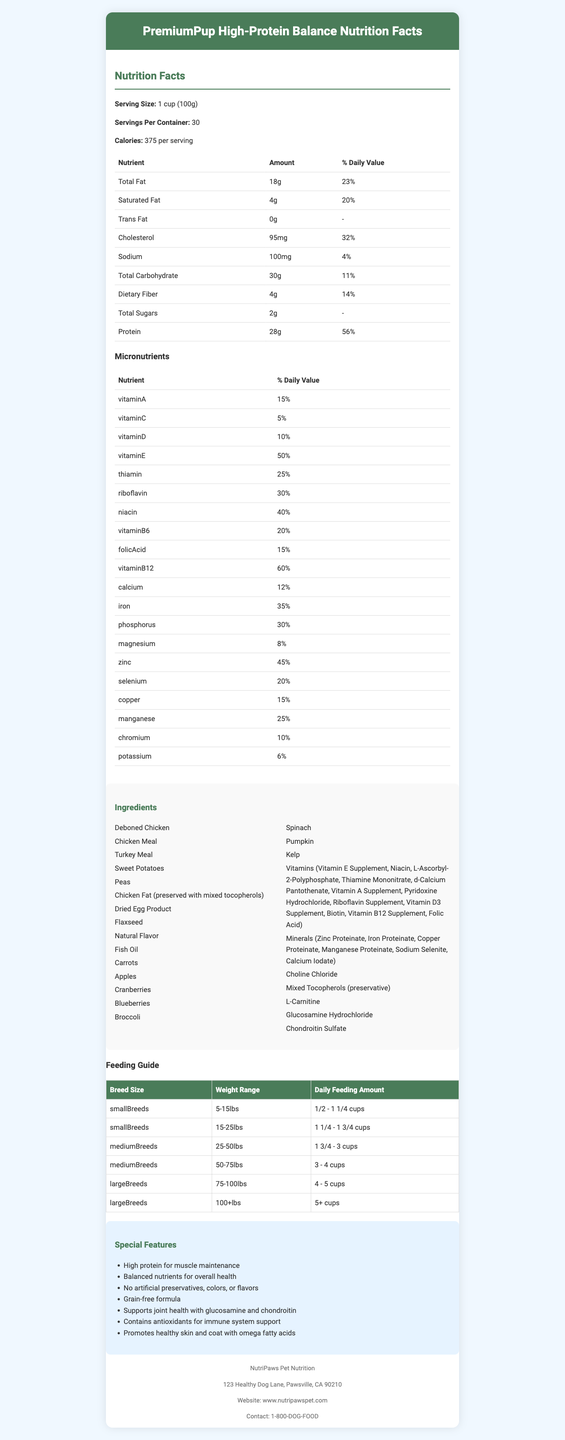What is the serving size for PremiumPup High-Protein Balance? The serving size is explicitly stated in the document as "1 cup (100g)".
Answer: 1 cup (100g) How many calories are there per serving? The document lists the calories per serving as 375.
Answer: 375 What is the minimum percentage of crude protein in the food? The guaranteed analysis section specifies a minimum of 28% crude protein.
Answer: 28% min How many servings are in one container? The document indicates that there are 30 servings per container.
Answer: 30 What is the percentage of the daily value for protein per serving? The nutrition facts section lists the daily value for protein as 56%.
Answer: 56% Which type of fatty acids are present in this dog food? A. Omega-6 B. Omega-3 C. Both Omega-6 and Omega-3 D. None of the above The document mentions that the food contains Omega-6 Fatty Acids (3% min) and Omega-3 Fatty Acids (0.5% min).
Answer: C How much saturated fat is in one serving? A. 2g B. 4g C. 6g D. 8g The amount of saturated fat is listed as 4g per serving.
Answer: B True or False: This dog food contains artificial preservatives. The special features section specifies that the product contains "No artificial preservatives, colors, or flavors".
Answer: False How much glucosamine is present per kilogram? The guaranteed analysis section states that the food contains a minimum of 800 mg/kg glucosamine.
Answer: 800 mg/kg min Which vitamins are included in the micronutrients? List at least three. The document lists several vitamins including Vitamin A, Vitamin C, and Vitamin D.
Answer: Vitamin A, Vitamin C, Vitamin D For which breed size is feeding 5 cups daily recommended? According to the feeding guide, large breeds between 75-100lbs should be fed 4 - 5 cups daily.
Answer: Large Breeds, 75-100lbs Summarize the key features of this dog food product. The document describes PremiumPup High-Protein Balance as a nutrient-rich dog food that is tailored for adult dogs of all sizes, promoting overall health and specific benefits such as joint and skin health.
Answer: PremiumPup High-Protein Balance is a high-protein, balanced nutrient dog food designed for adult dogs of all breeds. It contains no artificial preservatives, colors, or flavors and is grain-free. The food supports muscle maintenance, joint health, immune system, and promotes healthy skin and coat with omega fatty acids. What is the contact phone number for NutriPaws Pet Nutrition? The manufacturer's information section lists their contact phone number as 1-800-DOG-FOOD.
Answer: 1-800-DOG-FOOD Which ingredient is NOT listed in the document? A. Deboned Chicken B. Sweet Potatoes C. Rice D. Fish Oil Rice is not listed among the ingredients outlined in the document.
Answer: C What is the percentage of daily value for calcium? The nutrition facts indicate that the daily value percentage for calcium is 12%.
Answer: 12% Can this food be given to puppies? The document specifies it is for adult dogs of all breeds but does not provide information regarding puppies.
Answer: Cannot be determined 